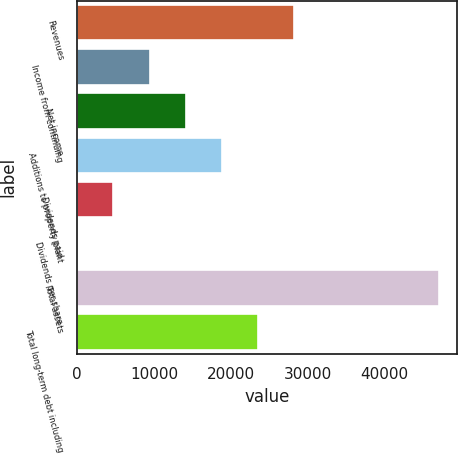Convert chart. <chart><loc_0><loc_0><loc_500><loc_500><bar_chart><fcel>Revenues<fcel>Income from continuing<fcel>Net income<fcel>Additions to property plant<fcel>Dividends paid<fcel>Dividends per share<fcel>Total assets<fcel>Total long-term debt including<nl><fcel>28231.6<fcel>9411.16<fcel>14116.3<fcel>18821.4<fcel>4706.06<fcel>0.96<fcel>47052<fcel>23526.5<nl></chart> 